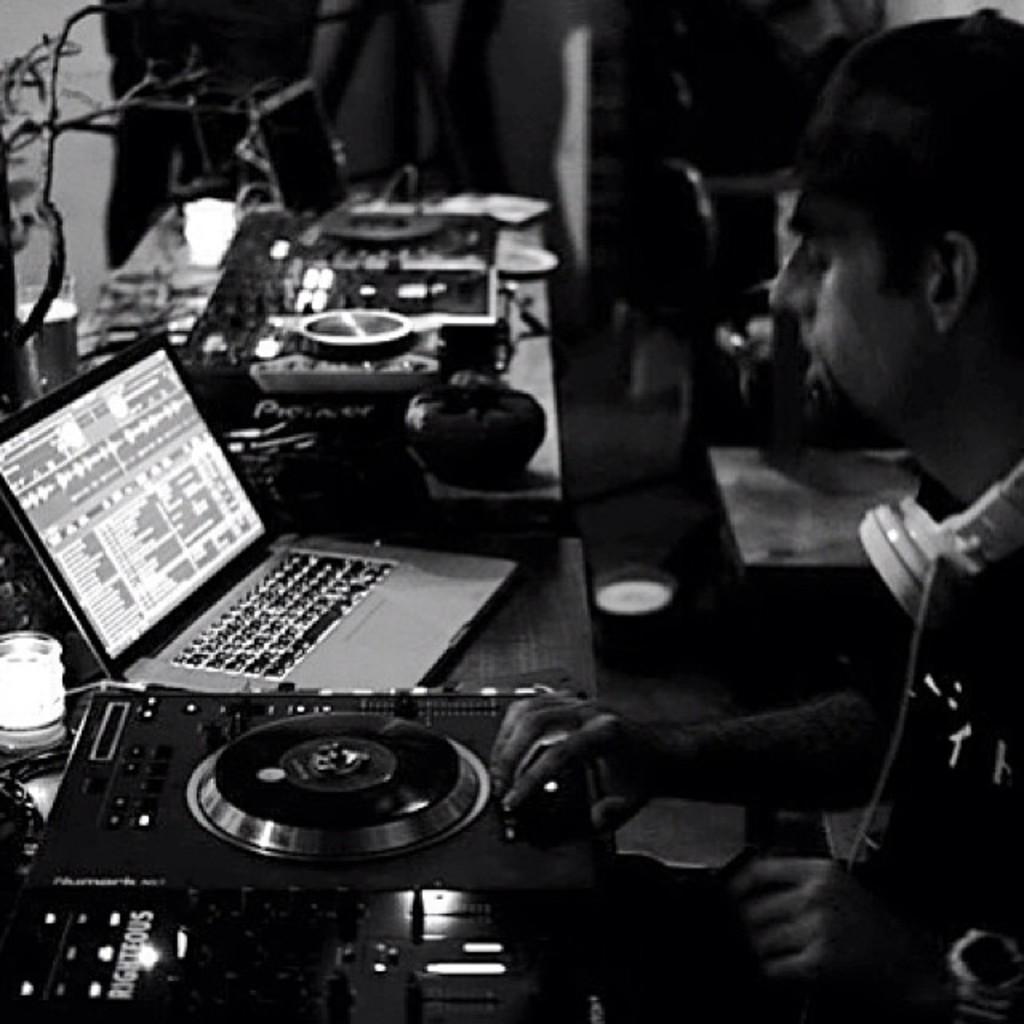Can you describe this image briefly? The person is sitting in the right corner and there is an amplifier in front of him and there is a laptop beside it and there are few other objects placed beside it on a table. 